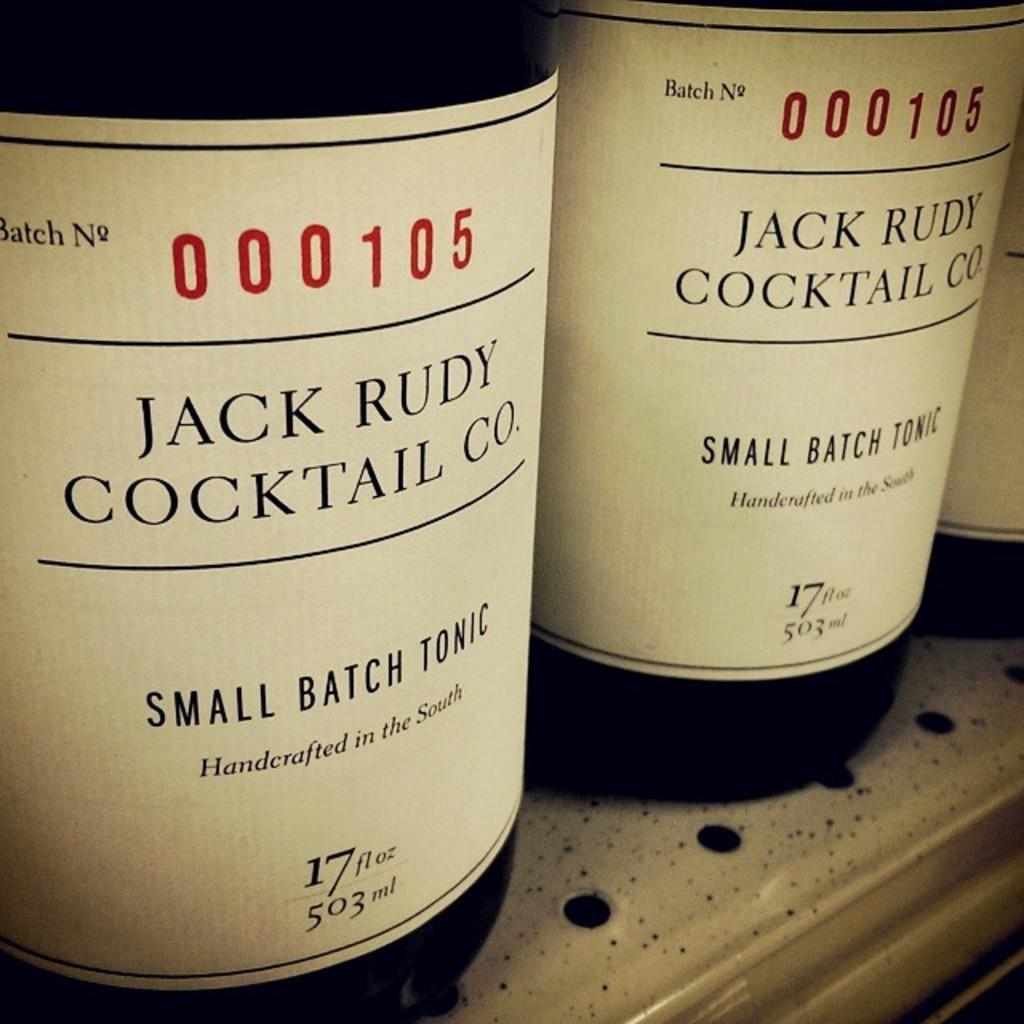<image>
Create a compact narrative representing the image presented. A row of Jack Rudy Cocktail Co Small batch tonic on a shelf. 